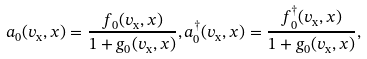Convert formula to latex. <formula><loc_0><loc_0><loc_500><loc_500>a _ { 0 } ( v _ { \text {x} } , x ) = \frac { f _ { 0 } ( v _ { \text {x} } , x ) } { 1 + g _ { 0 } ( v _ { \text {x} } , x ) } , a ^ { \dagger } _ { 0 } ( v _ { \text {x} } , x ) = \frac { f ^ { \dagger } _ { 0 } ( v _ { \text {x} } , x ) } { 1 + g _ { 0 } ( v _ { \text {x} } , x ) } ,</formula> 